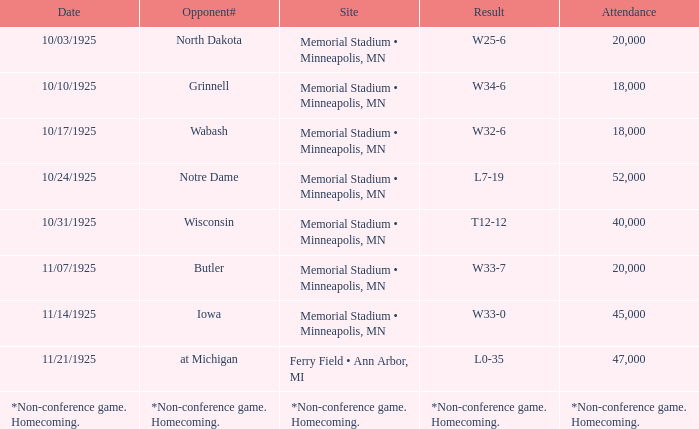Who was the opponent at the game attended by 45,000? Iowa. 